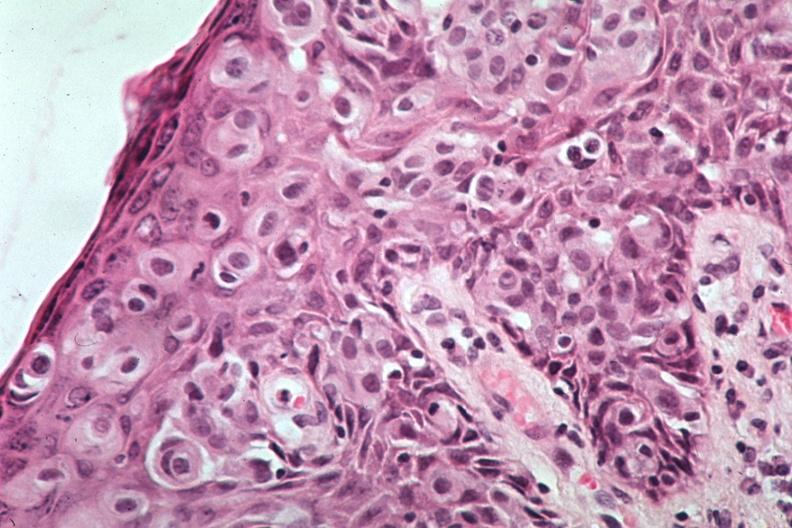s mesothelioma present?
Answer the question using a single word or phrase. No 